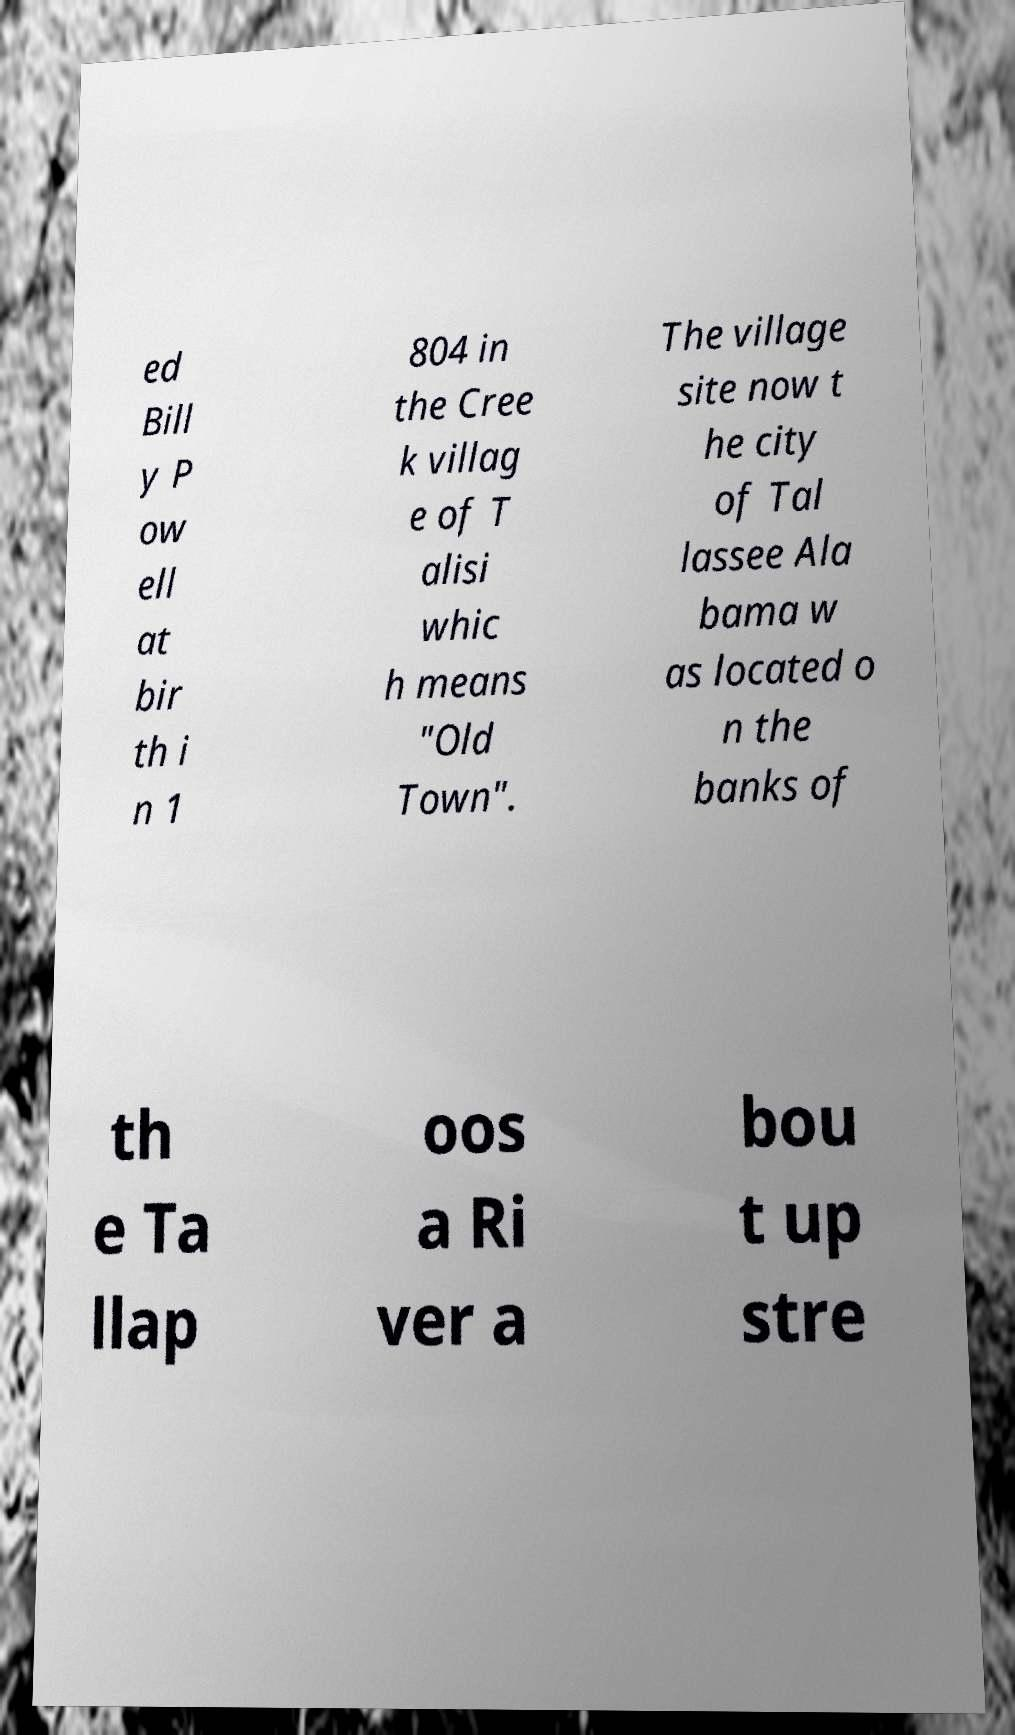For documentation purposes, I need the text within this image transcribed. Could you provide that? ed Bill y P ow ell at bir th i n 1 804 in the Cree k villag e of T alisi whic h means "Old Town". The village site now t he city of Tal lassee Ala bama w as located o n the banks of th e Ta llap oos a Ri ver a bou t up stre 